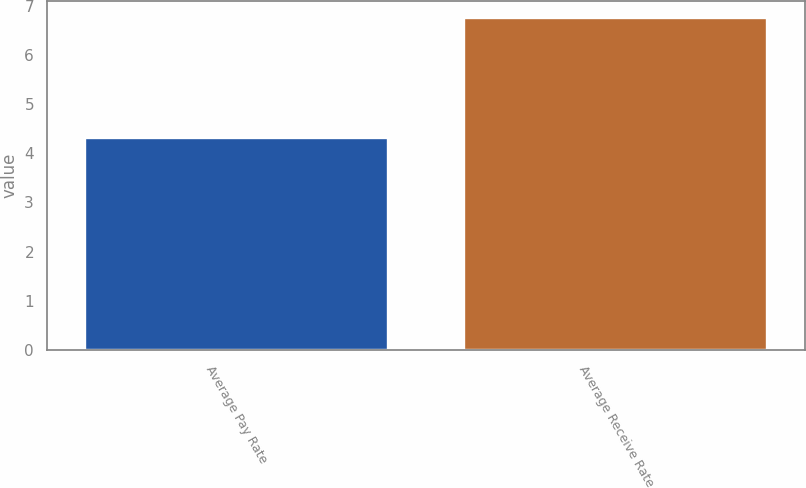Convert chart. <chart><loc_0><loc_0><loc_500><loc_500><bar_chart><fcel>Average Pay Rate<fcel>Average Receive Rate<nl><fcel>4.31<fcel>6.75<nl></chart> 